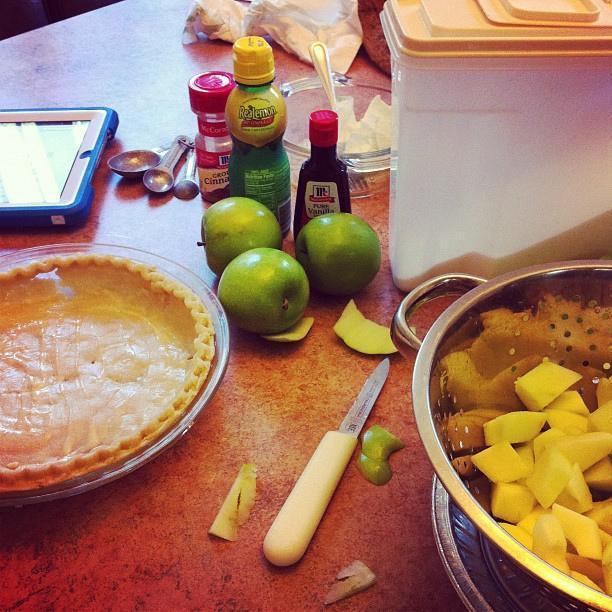How many apples are there?
Give a very brief answer. 3. How many of these fruits can be eaten without removing the peel?
Give a very brief answer. 3. How many donuts are pictured?
Give a very brief answer. 0. How many apples are visible?
Give a very brief answer. 2. How many bowls are in the photo?
Give a very brief answer. 2. How many bottles are there?
Give a very brief answer. 3. 